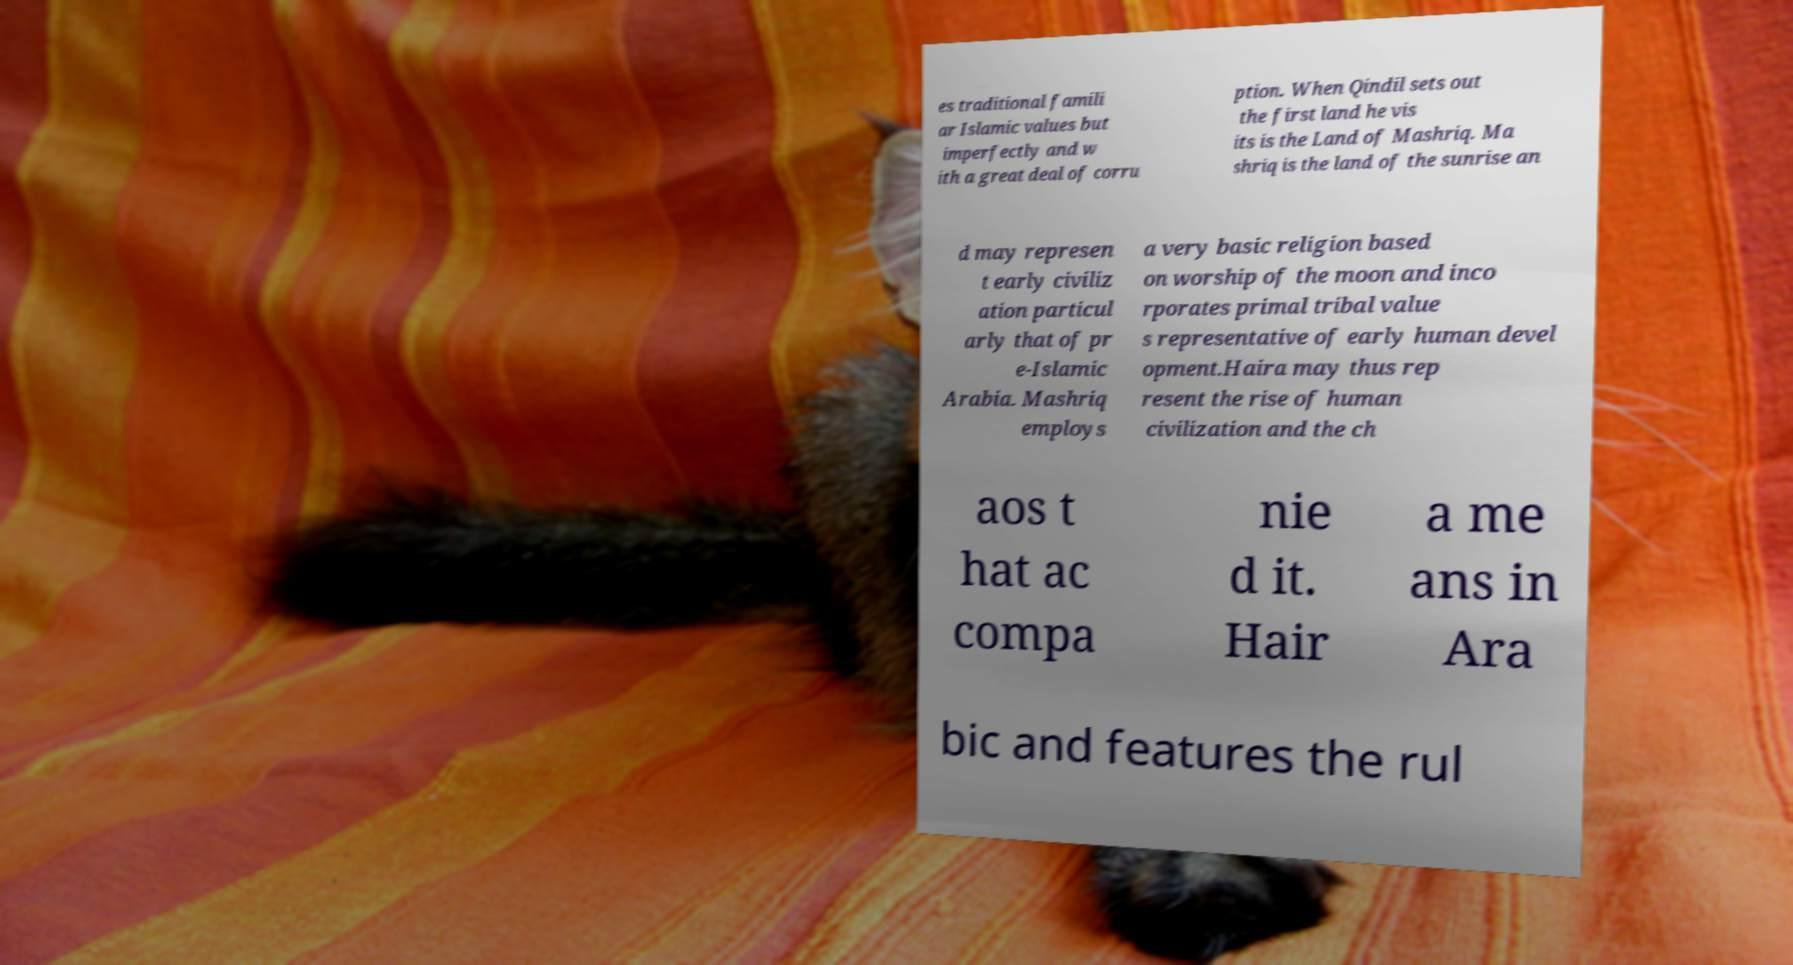Can you read and provide the text displayed in the image?This photo seems to have some interesting text. Can you extract and type it out for me? es traditional famili ar Islamic values but imperfectly and w ith a great deal of corru ption. When Qindil sets out the first land he vis its is the Land of Mashriq. Ma shriq is the land of the sunrise an d may represen t early civiliz ation particul arly that of pr e-Islamic Arabia. Mashriq employs a very basic religion based on worship of the moon and inco rporates primal tribal value s representative of early human devel opment.Haira may thus rep resent the rise of human civilization and the ch aos t hat ac compa nie d it. Hair a me ans in Ara bic and features the rul 